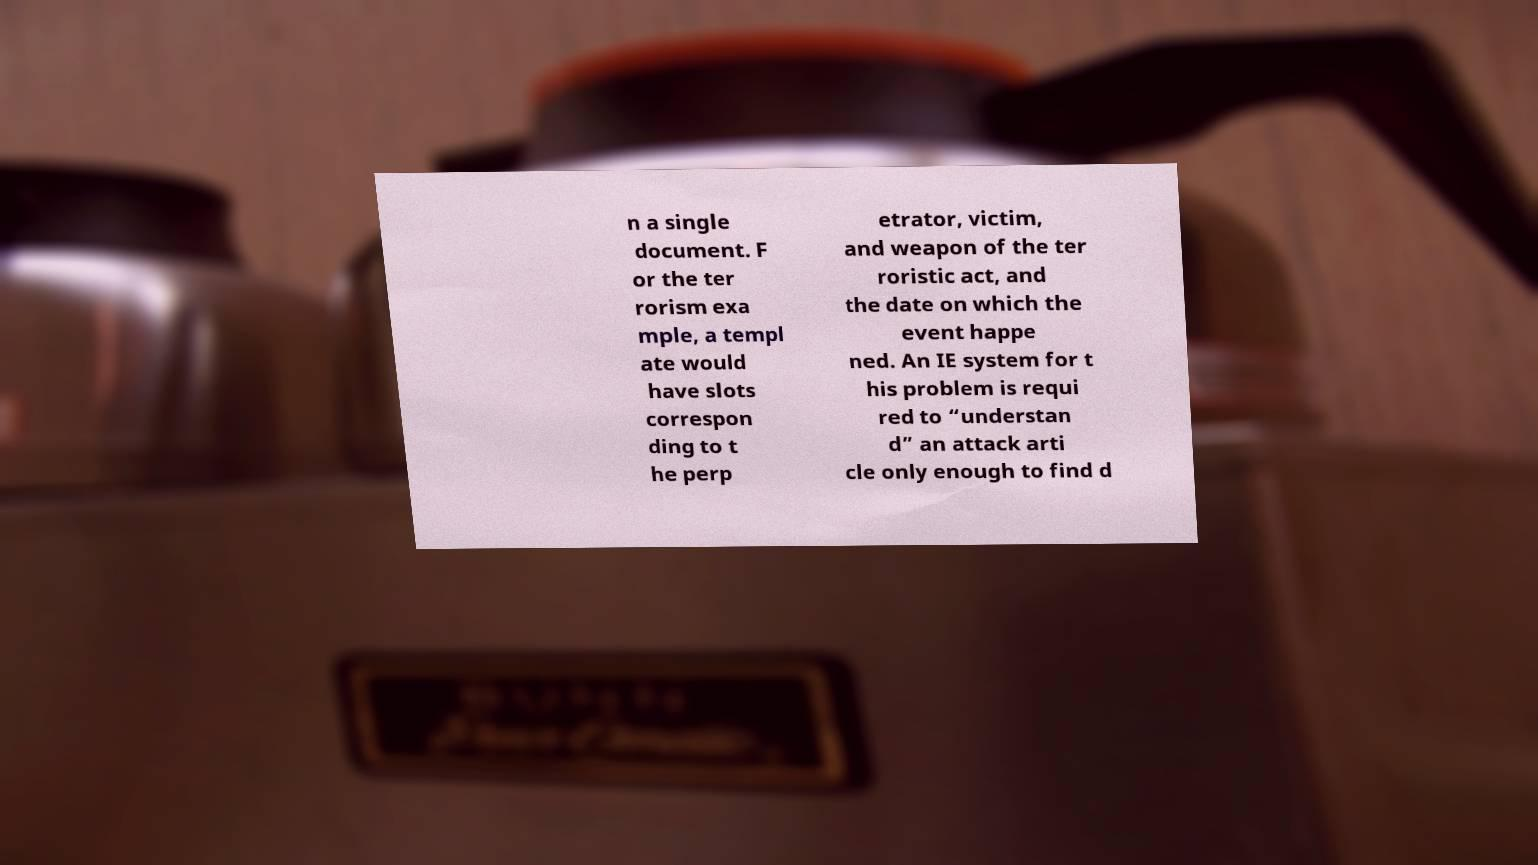There's text embedded in this image that I need extracted. Can you transcribe it verbatim? n a single document. F or the ter rorism exa mple, a templ ate would have slots correspon ding to t he perp etrator, victim, and weapon of the ter roristic act, and the date on which the event happe ned. An IE system for t his problem is requi red to “understan d” an attack arti cle only enough to find d 